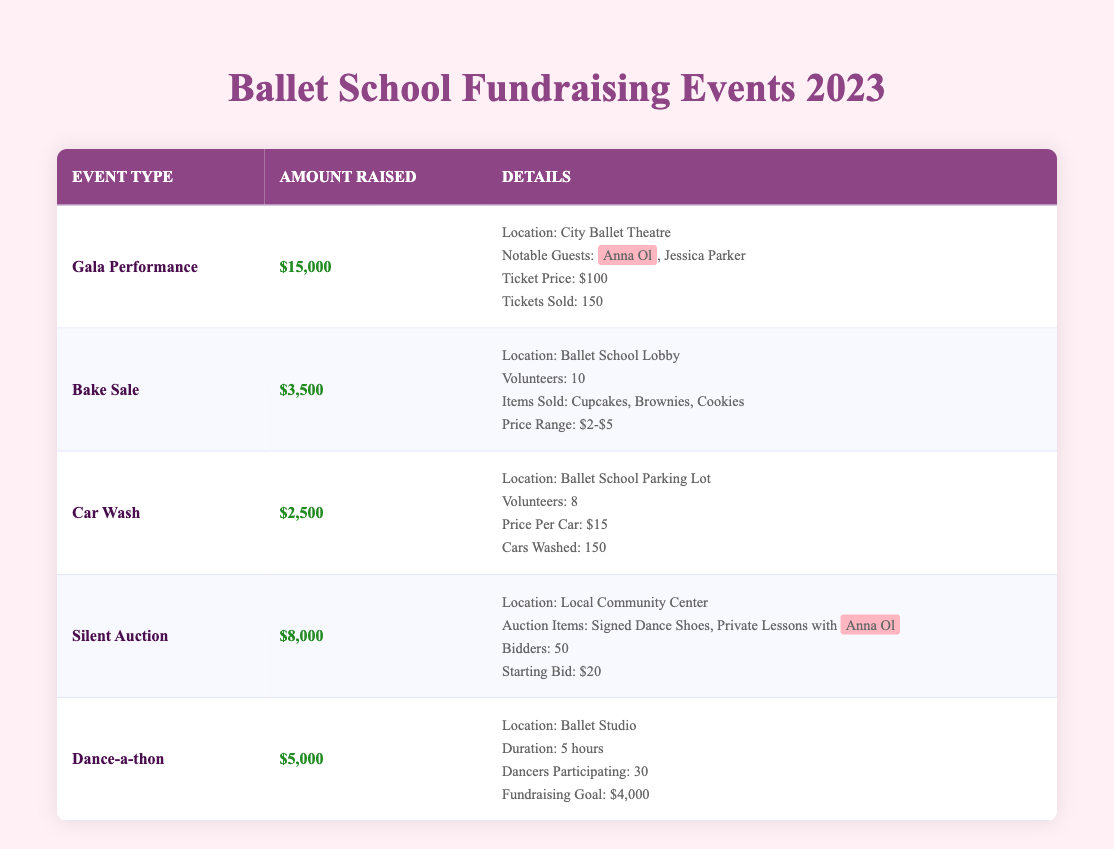What is the total amount raised from all fundraising events in 2023? To find the total amount raised, add the amounts from each event: 15,000 (Gala Performance) + 3,500 (Bake Sale) + 2,500 (Car Wash) + 8,000 (Silent Auction) + 5,000 (Dance-a-thon) = 34,000.
Answer: 34,000 Which event raised the most money? The highest amount raised is 15,000 by the Gala Performance.
Answer: Gala Performance How many tickets were sold for the Gala Performance? The table specifies that 150 tickets were sold for the Gala Performance.
Answer: 150 Did the Dance-a-thon exceed its fundraising goal? The Dance-a-thon raised 5,000 and had a fundraising goal of 4,000; since 5,000 is greater than 4,000, the goal was exceeded.
Answer: Yes What is the average amount raised per event? There are five events. The total raised amount is 34,000. To find the average, divide by the number of events: 34,000 / 5 = 6,800.
Answer: 6,800 Which event had the least amount raised, and what was that amount? The Car Wash had the least amount raised, which is 2,500, as seen in the table comparing the amounts for each event.
Answer: Car Wash, 2,500 How many volunteers participated in the Bake Sale? The table indicates that 10 volunteers participated in the Bake Sale.
Answer: 10 How many auction items were listed for the Silent Auction? The Silent Auction listed 2 specific auction items: Signed Dance Shoes and Private Lessons with Anna Ol, as mentioned in its details.
Answer: 2 What was the price per car for the Car Wash? The price per car for the Car Wash is stated as 15 in the details of that event in the table.
Answer: 15 